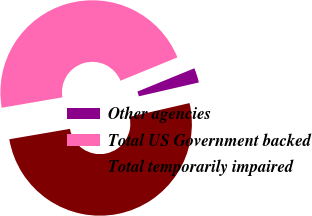Convert chart. <chart><loc_0><loc_0><loc_500><loc_500><pie_chart><fcel>Other agencies<fcel>Total US Government backed<fcel>Total temporarily impaired<nl><fcel>2.58%<fcel>46.51%<fcel>50.9%<nl></chart> 